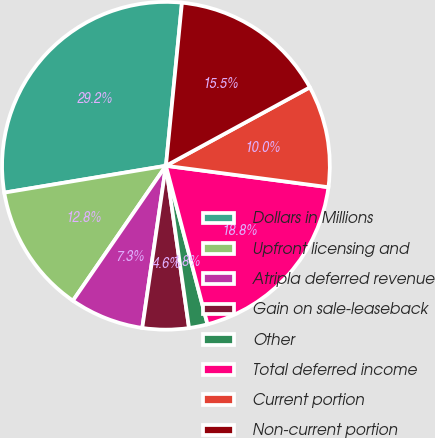<chart> <loc_0><loc_0><loc_500><loc_500><pie_chart><fcel>Dollars in Millions<fcel>Upfront licensing and<fcel>Atripla deferred revenue<fcel>Gain on sale-leaseback<fcel>Other<fcel>Total deferred income<fcel>Current portion<fcel>Non-current portion<nl><fcel>29.18%<fcel>12.77%<fcel>7.3%<fcel>4.56%<fcel>1.83%<fcel>18.83%<fcel>10.03%<fcel>15.5%<nl></chart> 